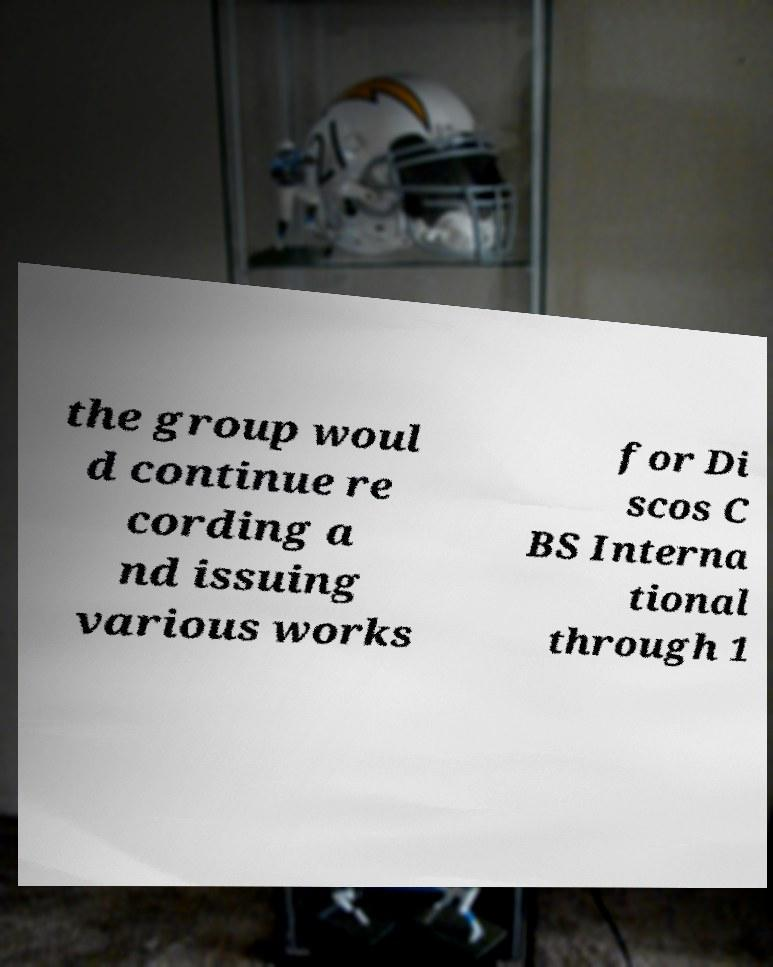What messages or text are displayed in this image? I need them in a readable, typed format. the group woul d continue re cording a nd issuing various works for Di scos C BS Interna tional through 1 